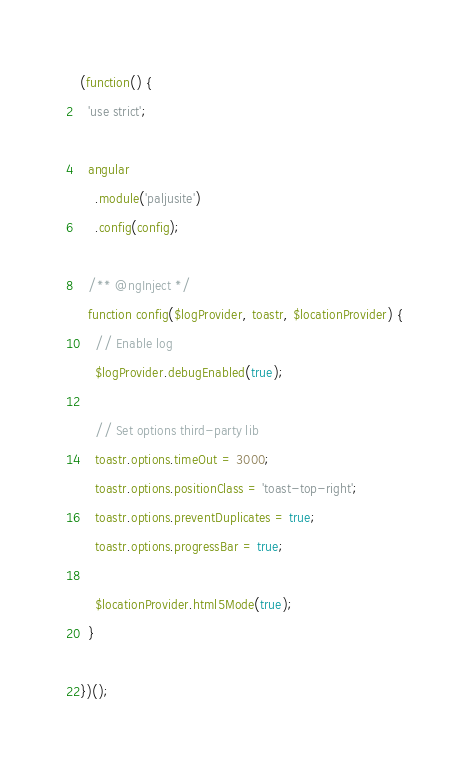Convert code to text. <code><loc_0><loc_0><loc_500><loc_500><_JavaScript_>(function() {
  'use strict';

  angular
    .module('paljusite')
    .config(config);

  /** @ngInject */
  function config($logProvider, toastr, $locationProvider) {
    // Enable log
    $logProvider.debugEnabled(true);

    // Set options third-party lib
    toastr.options.timeOut = 3000;
    toastr.options.positionClass = 'toast-top-right';
    toastr.options.preventDuplicates = true;
    toastr.options.progressBar = true;

    $locationProvider.html5Mode(true);
  }

})();
</code> 